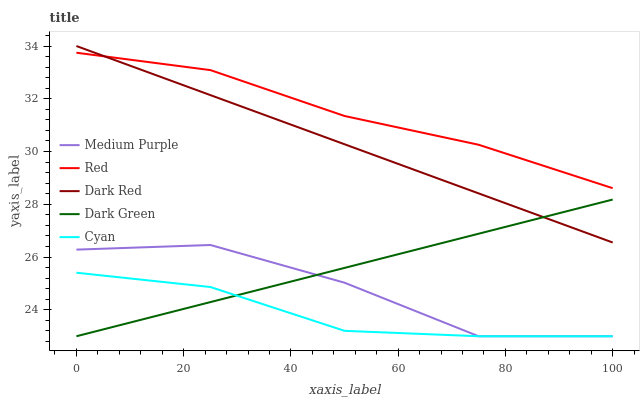Does Cyan have the minimum area under the curve?
Answer yes or no. Yes. Does Red have the maximum area under the curve?
Answer yes or no. Yes. Does Dark Red have the minimum area under the curve?
Answer yes or no. No. Does Dark Red have the maximum area under the curve?
Answer yes or no. No. Is Dark Green the smoothest?
Answer yes or no. Yes. Is Medium Purple the roughest?
Answer yes or no. Yes. Is Dark Red the smoothest?
Answer yes or no. No. Is Dark Red the roughest?
Answer yes or no. No. Does Medium Purple have the lowest value?
Answer yes or no. Yes. Does Dark Red have the lowest value?
Answer yes or no. No. Does Dark Red have the highest value?
Answer yes or no. Yes. Does Cyan have the highest value?
Answer yes or no. No. Is Cyan less than Dark Red?
Answer yes or no. Yes. Is Red greater than Cyan?
Answer yes or no. Yes. Does Dark Red intersect Red?
Answer yes or no. Yes. Is Dark Red less than Red?
Answer yes or no. No. Is Dark Red greater than Red?
Answer yes or no. No. Does Cyan intersect Dark Red?
Answer yes or no. No. 